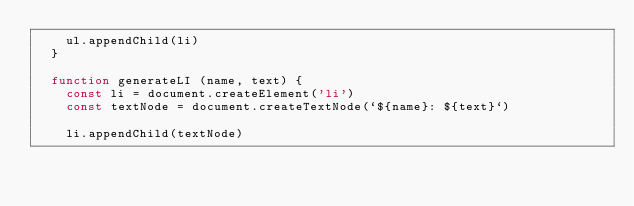<code> <loc_0><loc_0><loc_500><loc_500><_JavaScript_>    ul.appendChild(li)
  }

  function generateLI (name, text) {
    const li = document.createElement('li')
    const textNode = document.createTextNode(`${name}: ${text}`)

    li.appendChild(textNode)</code> 